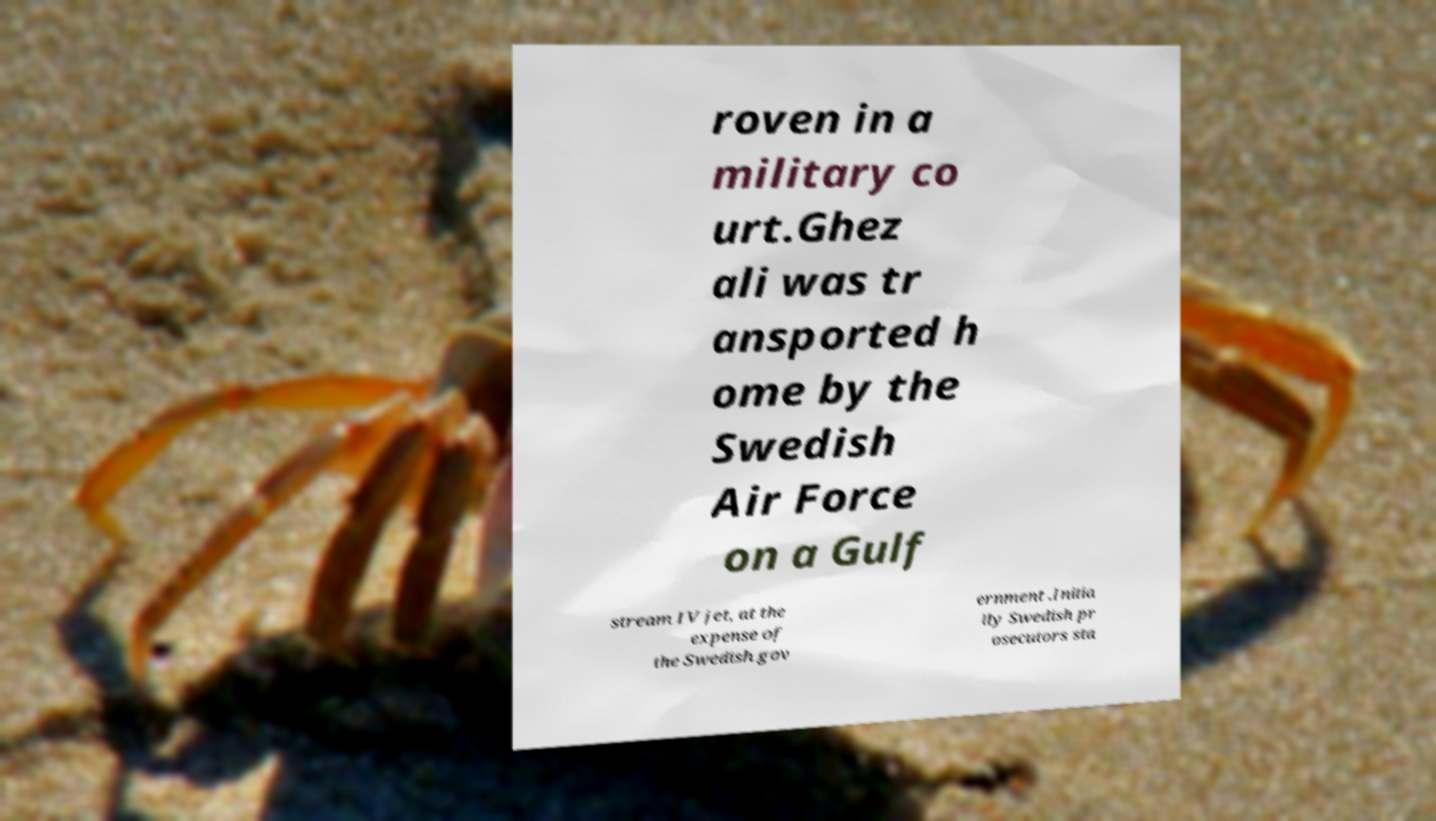What messages or text are displayed in this image? I need them in a readable, typed format. roven in a military co urt.Ghez ali was tr ansported h ome by the Swedish Air Force on a Gulf stream IV jet, at the expense of the Swedish gov ernment .Initia lly Swedish pr osecutors sta 